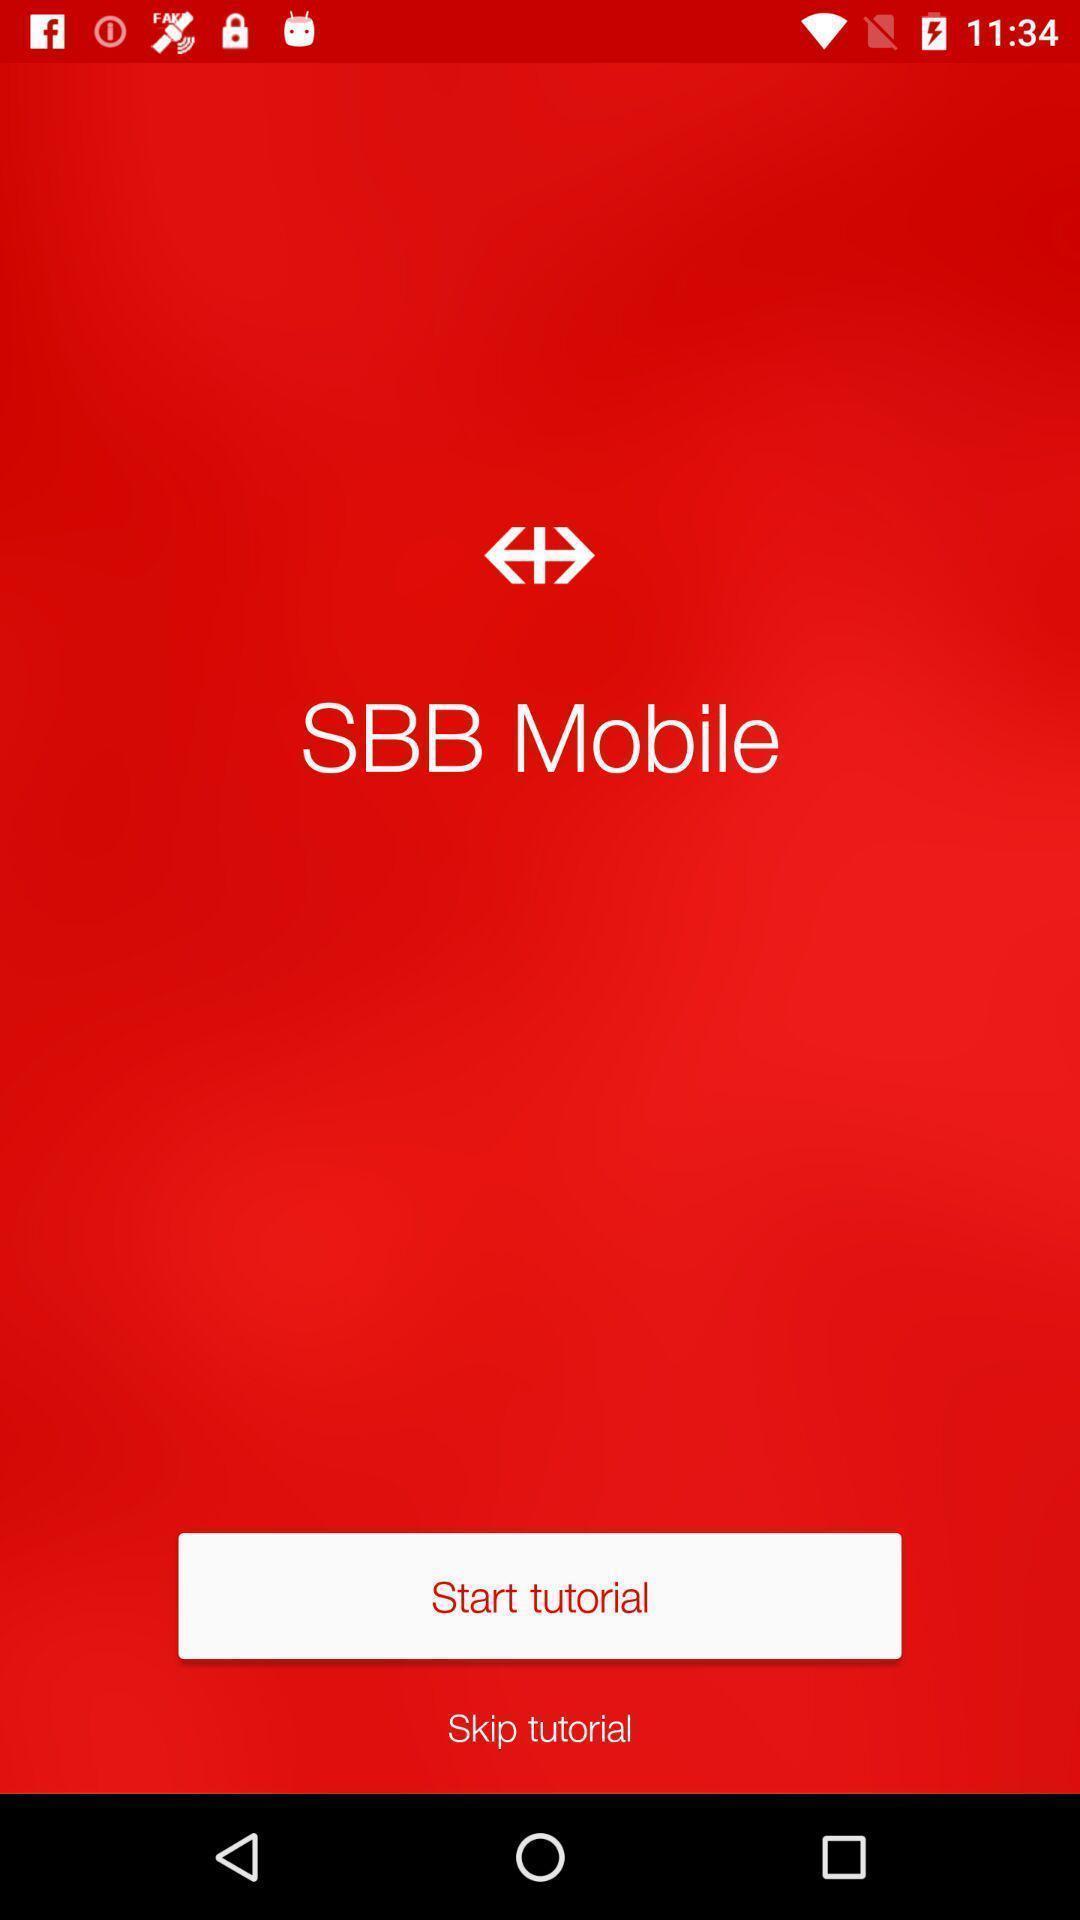Tell me what you see in this picture. Welcome page of public transport app. 